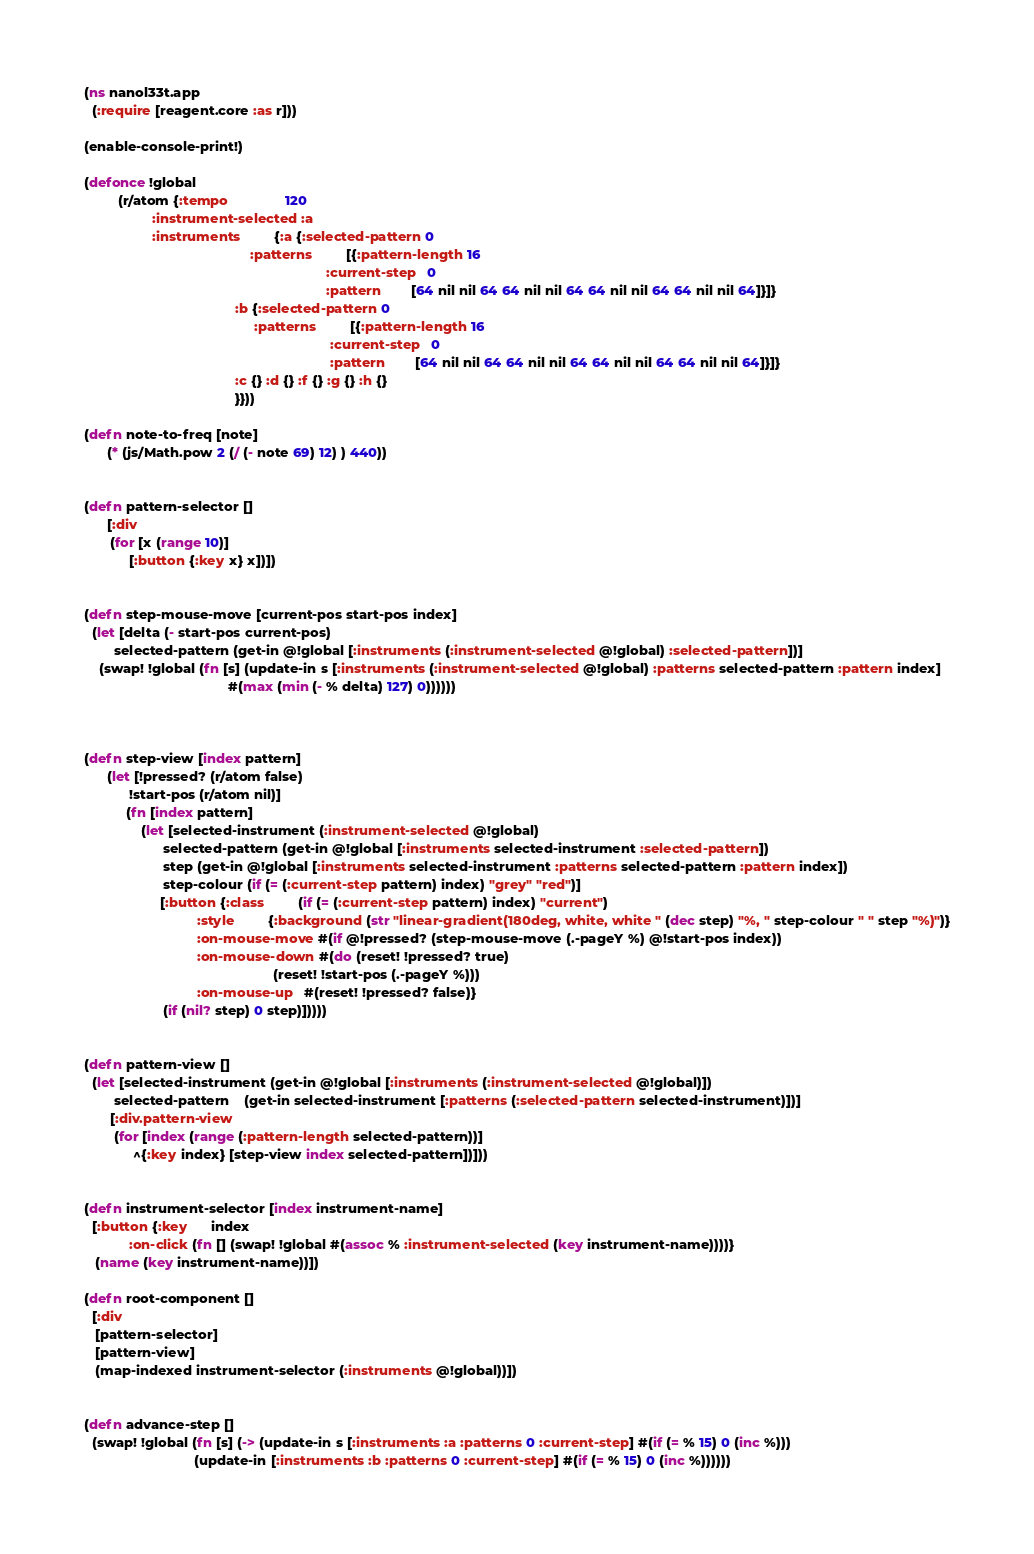Convert code to text. <code><loc_0><loc_0><loc_500><loc_500><_Clojure_>(ns nanol33t.app
  (:require [reagent.core :as r]))

(enable-console-print!)

(defonce !global
         (r/atom {:tempo               120
                  :instrument-selected :a
                  :instruments         {:a {:selected-pattern 0
                                            :patterns         [{:pattern-length 16
                                                                :current-step   0
                                                                :pattern        [64 nil nil 64 64 nil nil 64 64 nil nil 64 64 nil nil 64]}]}
                                        :b {:selected-pattern 0
                                             :patterns         [{:pattern-length 16
                                                                 :current-step   0
                                                                 :pattern        [64 nil nil 64 64 nil nil 64 64 nil nil 64 64 nil nil 64]}]}
                                        :c {} :d {} :f {} :g {} :h {}
                                        }}))

(defn note-to-freq [note]
      (* (js/Math.pow 2 (/ (- note 69) 12) ) 440))


(defn pattern-selector []
      [:div
       (for [x (range 10)]
            [:button {:key x} x])])


(defn step-mouse-move [current-pos start-pos index]
  (let [delta (- start-pos current-pos)
        selected-pattern (get-in @!global [:instruments (:instrument-selected @!global) :selected-pattern])]
    (swap! !global (fn [s] (update-in s [:instruments (:instrument-selected @!global) :patterns selected-pattern :pattern index]
                                      #(max (min (- % delta) 127) 0))))))



(defn step-view [index pattern]
      (let [!pressed? (r/atom false)
            !start-pos (r/atom nil)]
           (fn [index pattern]
               (let [selected-instrument (:instrument-selected @!global)
                     selected-pattern (get-in @!global [:instruments selected-instrument :selected-pattern])
                     step (get-in @!global [:instruments selected-instrument :patterns selected-pattern :pattern index])
                     step-colour (if (= (:current-step pattern) index) "grey" "red")]
                    [:button {:class         (if (= (:current-step pattern) index) "current")
                              :style         {:background (str "linear-gradient(180deg, white, white " (dec step) "%, " step-colour " " step "%)")}
                              :on-mouse-move #(if @!pressed? (step-mouse-move (.-pageY %) @!start-pos index))
                              :on-mouse-down #(do (reset! !pressed? true)
                                                  (reset! !start-pos (.-pageY %)))
                              :on-mouse-up   #(reset! !pressed? false)}
                     (if (nil? step) 0 step)]))))


(defn pattern-view []
  (let [selected-instrument (get-in @!global [:instruments (:instrument-selected @!global)])
        selected-pattern    (get-in selected-instrument [:patterns (:selected-pattern selected-instrument)])]
       [:div.pattern-view
        (for [index (range (:pattern-length selected-pattern))]
             ^{:key index} [step-view index selected-pattern])]))


(defn instrument-selector [index instrument-name]
  [:button {:key      index
            :on-click (fn [] (swap! !global #(assoc % :instrument-selected (key instrument-name))))}
   (name (key instrument-name))])

(defn root-component []
  [:div
   [pattern-selector]
   [pattern-view]
   (map-indexed instrument-selector (:instruments @!global))])


(defn advance-step []
  (swap! !global (fn [s] (-> (update-in s [:instruments :a :patterns 0 :current-step] #(if (= % 15) 0 (inc %)))
                             (update-in [:instruments :b :patterns 0 :current-step] #(if (= % 15) 0 (inc %))))))</code> 